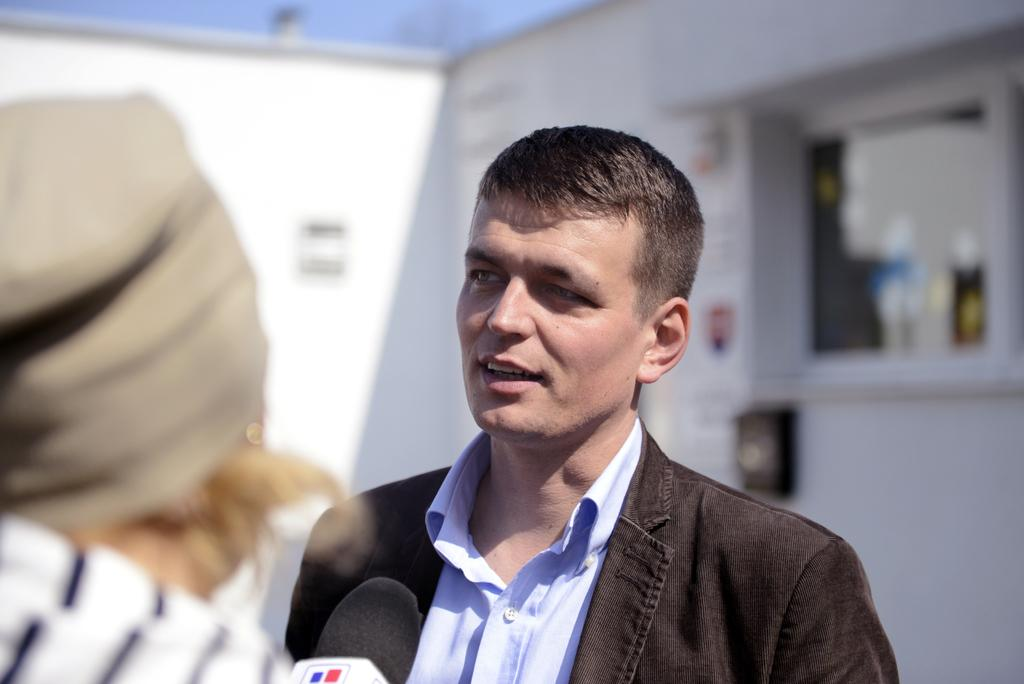How many people are in the image? There are two persons in the image. What object can be seen in the image that is typically used for amplifying sound? There is a microphone in the image. Can you describe the background of the image? The background of the image is blurred. What type of cat can be seen laughing in the image? There is no cat or laughter present in the image. 